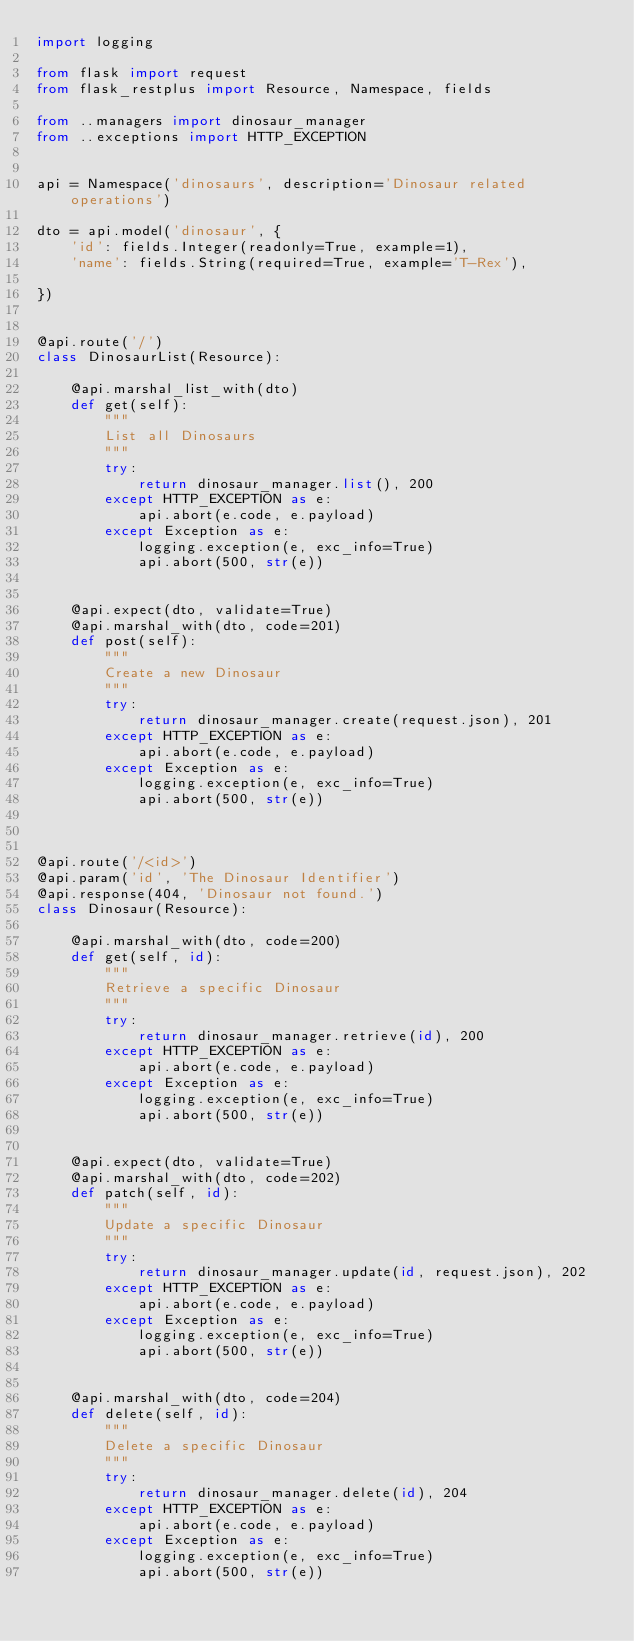<code> <loc_0><loc_0><loc_500><loc_500><_Python_>import logging

from flask import request
from flask_restplus import Resource, Namespace, fields

from ..managers import dinosaur_manager
from ..exceptions import HTTP_EXCEPTION


api = Namespace('dinosaurs', description='Dinosaur related operations')

dto = api.model('dinosaur', {
    'id': fields.Integer(readonly=True, example=1),
    'name': fields.String(required=True, example='T-Rex'),

})


@api.route('/')
class DinosaurList(Resource):

    @api.marshal_list_with(dto)
    def get(self):
        """
        List all Dinosaurs
        """
        try:
            return dinosaur_manager.list(), 200
        except HTTP_EXCEPTION as e:
            api.abort(e.code, e.payload)
        except Exception as e:
            logging.exception(e, exc_info=True)
            api.abort(500, str(e))


    @api.expect(dto, validate=True)
    @api.marshal_with(dto, code=201)
    def post(self):
        """
        Create a new Dinosaur
        """
        try:
            return dinosaur_manager.create(request.json), 201
        except HTTP_EXCEPTION as e:
            api.abort(e.code, e.payload)
        except Exception as e:
            logging.exception(e, exc_info=True)
            api.abort(500, str(e))



@api.route('/<id>')
@api.param('id', 'The Dinosaur Identifier')
@api.response(404, 'Dinosaur not found.')
class Dinosaur(Resource):

    @api.marshal_with(dto, code=200)
    def get(self, id):
        """
        Retrieve a specific Dinosaur
        """
        try:
            return dinosaur_manager.retrieve(id), 200
        except HTTP_EXCEPTION as e:
            api.abort(e.code, e.payload)
        except Exception as e:
            logging.exception(e, exc_info=True)
            api.abort(500, str(e))


    @api.expect(dto, validate=True)
    @api.marshal_with(dto, code=202)
    def patch(self, id):
        """
        Update a specific Dinosaur
        """
        try:
            return dinosaur_manager.update(id, request.json), 202
        except HTTP_EXCEPTION as e:
            api.abort(e.code, e.payload)
        except Exception as e:
            logging.exception(e, exc_info=True)
            api.abort(500, str(e))


    @api.marshal_with(dto, code=204)
    def delete(self, id):
        """
        Delete a specific Dinosaur
        """
        try:
            return dinosaur_manager.delete(id), 204
        except HTTP_EXCEPTION as e:
            api.abort(e.code, e.payload)
        except Exception as e:
            logging.exception(e, exc_info=True)
            api.abort(500, str(e))
</code> 